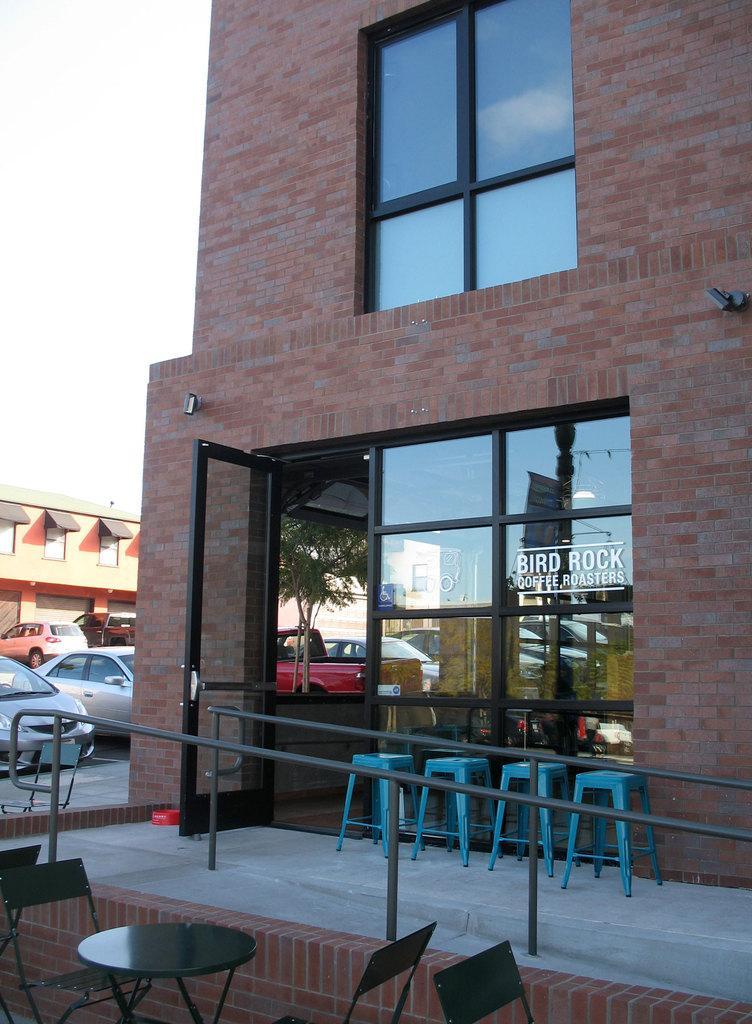Could you give a brief overview of what you see in this image? there is a building with a glass door at the bottom and a glass window at the top of it. the walls are made up of red bricks. in front of it there are stools. in front of the building there is a table and chairs, behind that there are cars and other buildings. 